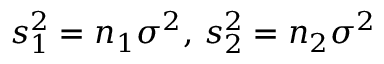<formula> <loc_0><loc_0><loc_500><loc_500>s _ { 1 } ^ { 2 } = n _ { 1 } \sigma ^ { 2 } , \, s _ { 2 } ^ { 2 } = n _ { 2 } \sigma ^ { 2 }</formula> 